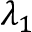Convert formula to latex. <formula><loc_0><loc_0><loc_500><loc_500>\lambda _ { 1 }</formula> 